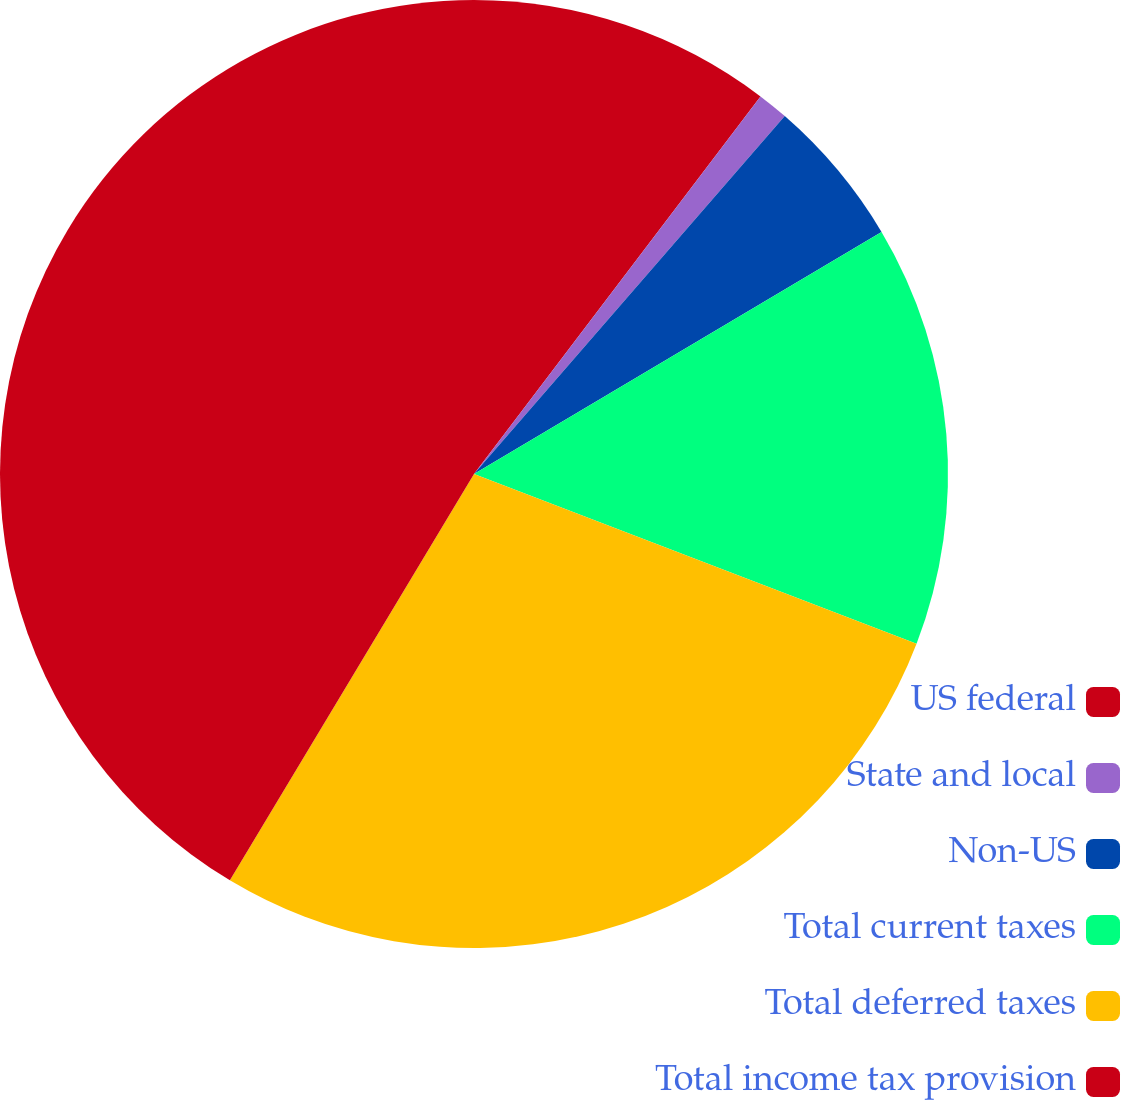Convert chart. <chart><loc_0><loc_0><loc_500><loc_500><pie_chart><fcel>US federal<fcel>State and local<fcel>Non-US<fcel>Total current taxes<fcel>Total deferred taxes<fcel>Total income tax provision<nl><fcel>10.33%<fcel>1.05%<fcel>5.09%<fcel>14.36%<fcel>27.78%<fcel>41.39%<nl></chart> 